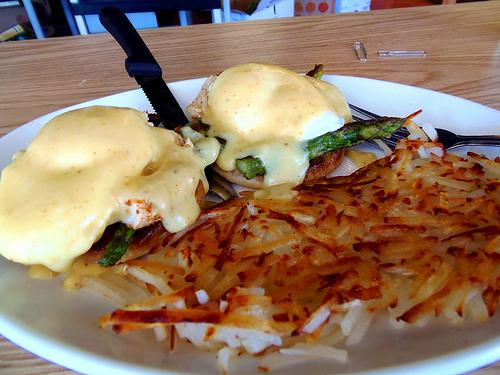Question: what is yellow?
Choices:
A. Eggs.
B. Flower.
C. Popcorn.
D. Cans.
Answer with the letter. Answer: A Question: where is a plate?
Choices:
A. On the counter.
B. On table.
C. In the cabinet.
D. To the left.
Answer with the letter. Answer: B Question: where was the photo taken?
Choices:
A. In a park.
B. At the wedding reception.
C. On the street.
D. Next to a table.
Answer with the letter. Answer: D Question: what is on a plate?
Choices:
A. Pizza.
B. Food.
C. Flower.
D. Spoons.
Answer with the letter. Answer: B Question: what is black?
Choices:
A. Table.
B. Plate.
C. Knife.
D. Bowl.
Answer with the letter. Answer: C Question: how many eggs are there?
Choices:
A. 1.
B. 3.
C. 2.
D. 4.
Answer with the letter. Answer: C Question: where are potatoes?
Choices:
A. On a plate.
B. In the pan.
C. In the oven.
D. On the table.
Answer with the letter. Answer: A 